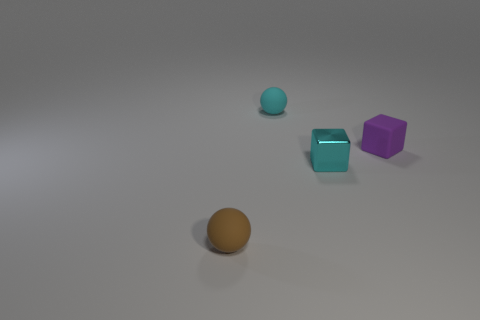Are there any other small metallic things that have the same shape as the shiny thing?
Your response must be concise. No. Does the purple rubber block have the same size as the rubber sphere in front of the tiny cyan block?
Your answer should be very brief. Yes. What number of objects are things in front of the cyan rubber object or cubes that are to the left of the small purple matte thing?
Your answer should be compact. 3. Are there more small cyan things that are right of the small brown rubber object than cyan metallic cubes?
Your answer should be compact. Yes. What number of cyan spheres have the same size as the purple rubber object?
Make the answer very short. 1. Does the matte ball that is on the right side of the brown ball have the same size as the brown matte sphere left of the cyan rubber ball?
Give a very brief answer. Yes. There is a block that is to the left of the tiny purple matte thing; what is its size?
Offer a very short reply. Small. What is the size of the ball that is behind the matte thing that is in front of the purple rubber cube?
Keep it short and to the point. Small. What material is the cyan object that is the same size as the cyan rubber ball?
Provide a short and direct response. Metal. There is a tiny matte cube; are there any brown things behind it?
Your response must be concise. No. 